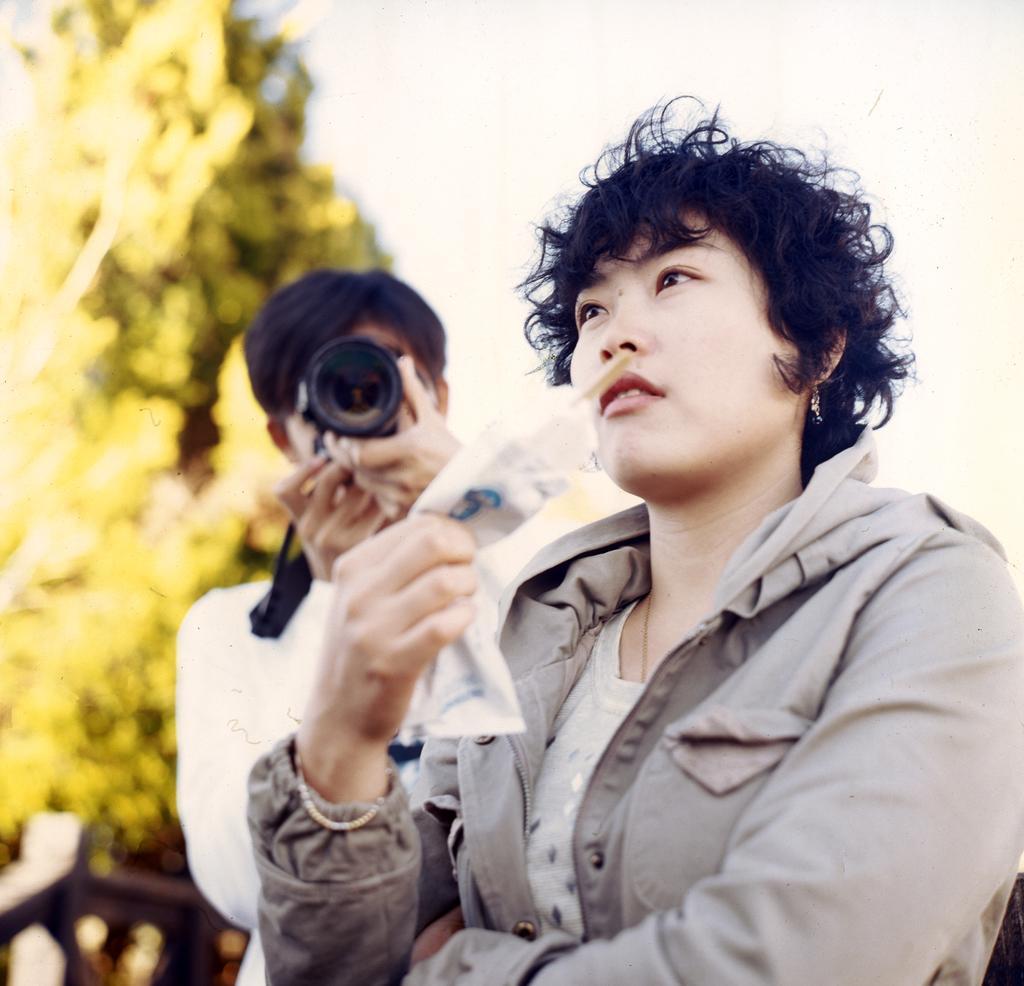Could you give a brief overview of what you see in this image? In this picture I can see a woman holding an object, behind one person holding camera and taking picture. 